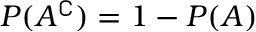<formula> <loc_0><loc_0><loc_500><loc_500>P ( A ^ { \complement } ) = 1 - P ( A )</formula> 